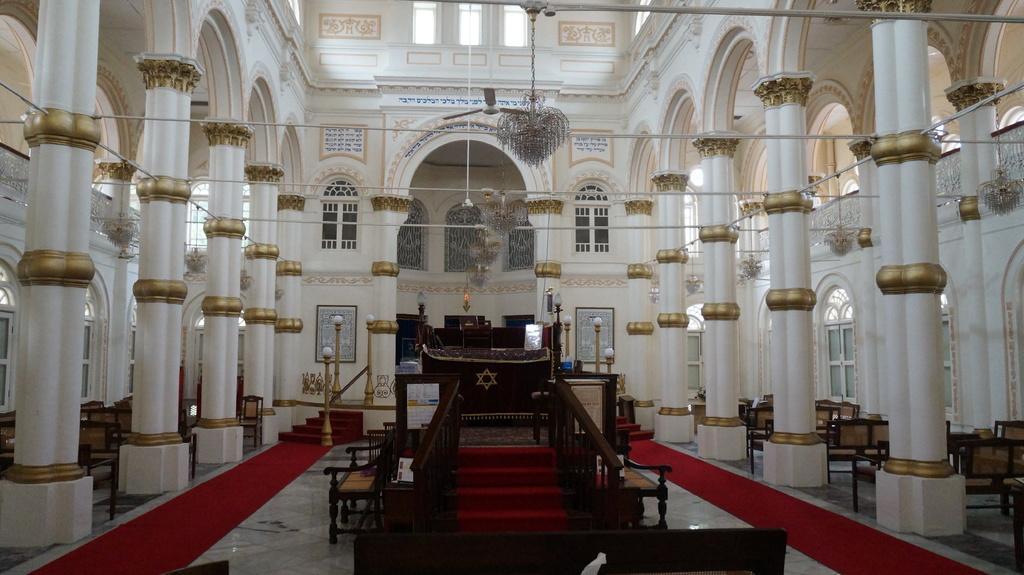Can you describe this image briefly? This is the picture of a building. In the foreground there is a staircase and there are chairs and there are objects on the table and there are lights and there frames on the wall. At the top there are chandeliers. At the bottom there are red carpets on the floor. On the left and on the right side of the image there are chairs and there are windows. 